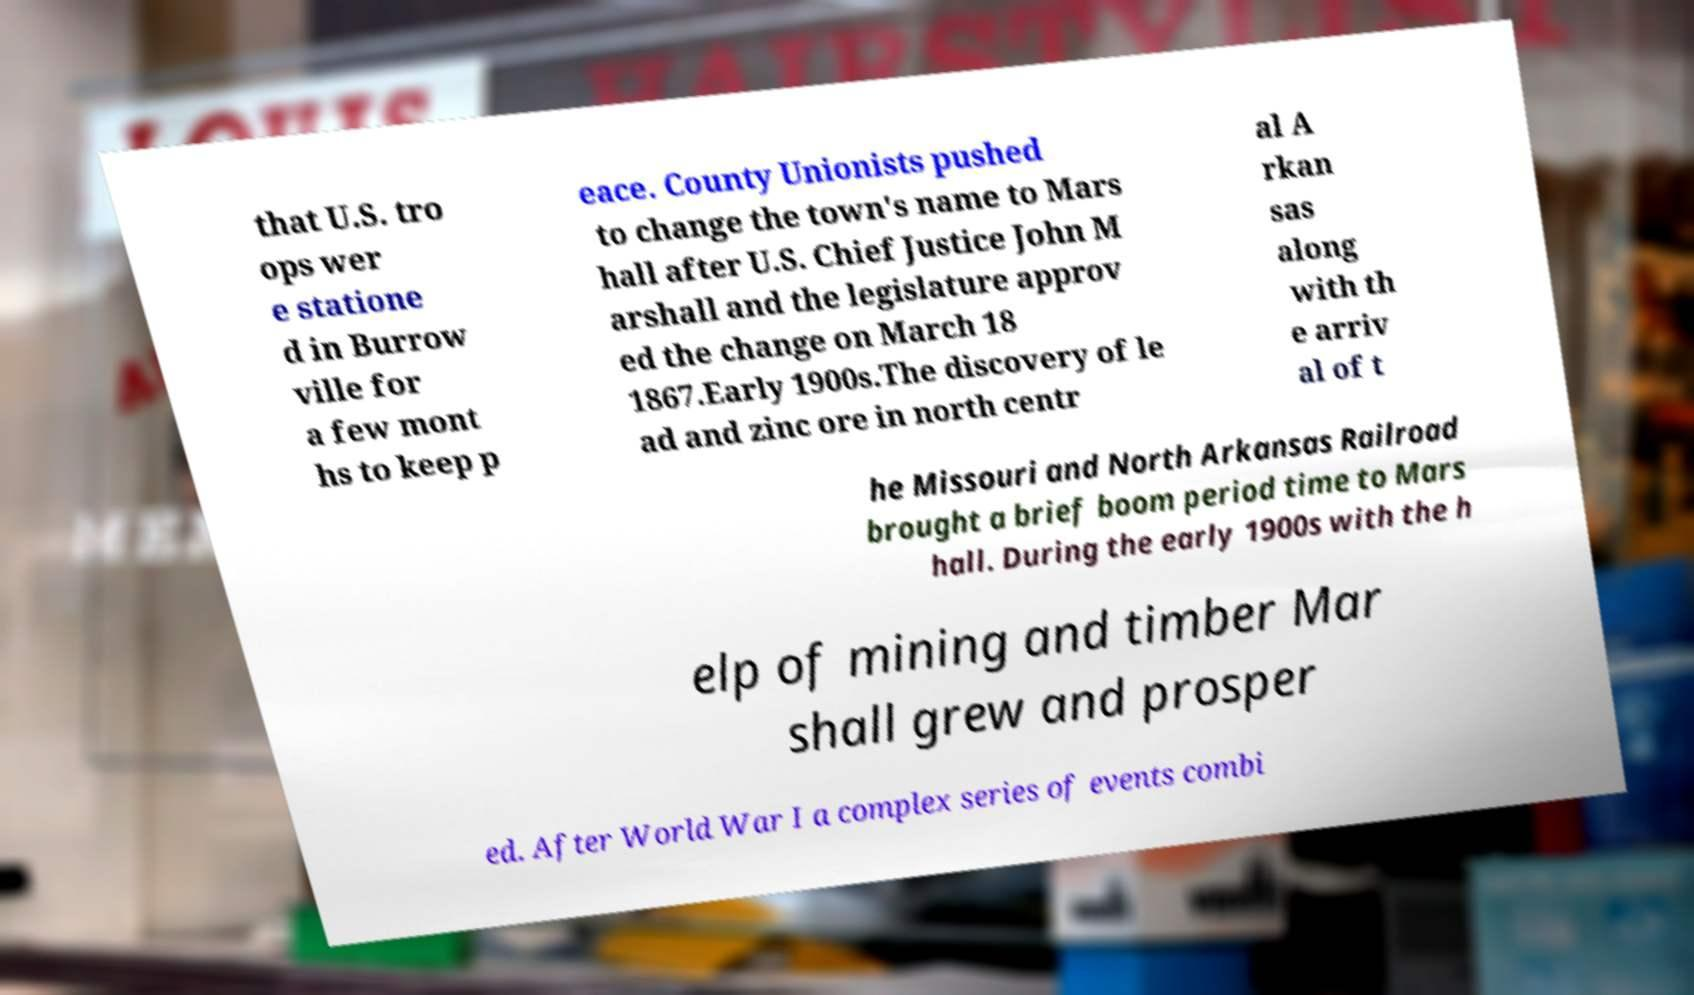For documentation purposes, I need the text within this image transcribed. Could you provide that? that U.S. tro ops wer e statione d in Burrow ville for a few mont hs to keep p eace. County Unionists pushed to change the town's name to Mars hall after U.S. Chief Justice John M arshall and the legislature approv ed the change on March 18 1867.Early 1900s.The discovery of le ad and zinc ore in north centr al A rkan sas along with th e arriv al of t he Missouri and North Arkansas Railroad brought a brief boom period time to Mars hall. During the early 1900s with the h elp of mining and timber Mar shall grew and prosper ed. After World War I a complex series of events combi 